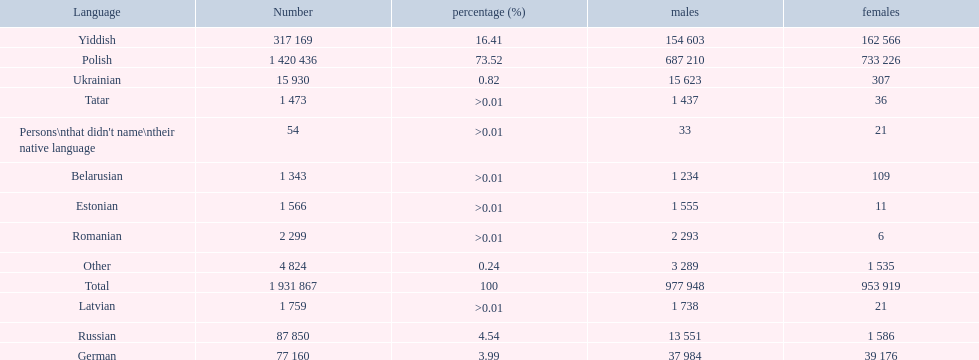What are all the languages? Polish, Yiddish, Russian, German, Ukrainian, Romanian, Latvian, Estonian, Tatar, Belarusian, Other, Persons\nthat didn't name\ntheir native language. Of those languages, which five had fewer than 50 females speaking it? 6, 21, 11, 36, 21. Of those five languages, which is the lowest? Romanian. 